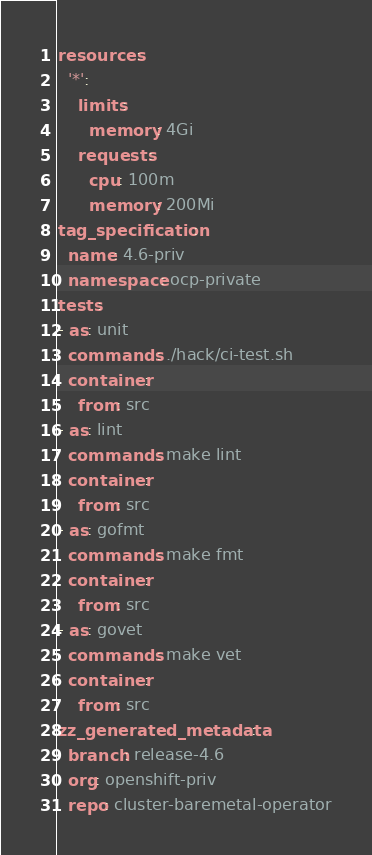Convert code to text. <code><loc_0><loc_0><loc_500><loc_500><_YAML_>resources:
  '*':
    limits:
      memory: 4Gi
    requests:
      cpu: 100m
      memory: 200Mi
tag_specification:
  name: 4.6-priv
  namespace: ocp-private
tests:
- as: unit
  commands: ./hack/ci-test.sh
  container:
    from: src
- as: lint
  commands: make lint
  container:
    from: src
- as: gofmt
  commands: make fmt
  container:
    from: src
- as: govet
  commands: make vet
  container:
    from: src
zz_generated_metadata:
  branch: release-4.6
  org: openshift-priv
  repo: cluster-baremetal-operator
</code> 